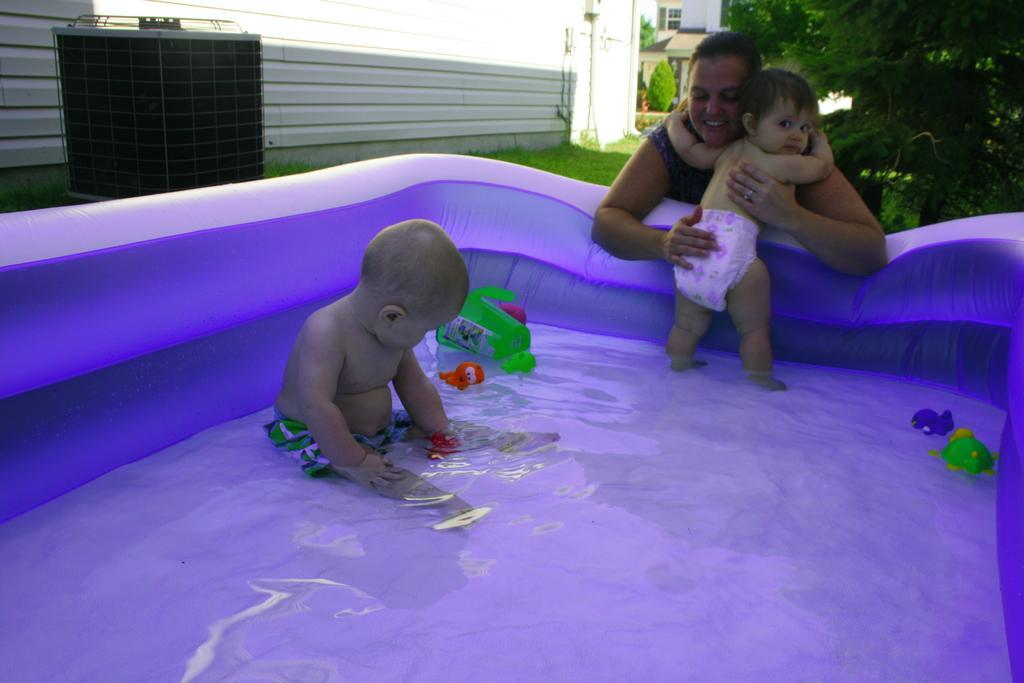Please provide a concise description of this image. There is an inflatable plastic bathtub with water. In that there is a baby sitting. Also there are toys. Near to that there is a lady holding a baby. In the back there is grass, trees and buildings. 